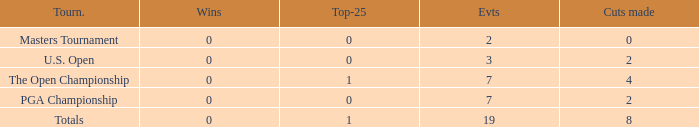What is the Wins of the Top-25 of 1 and 7 Events? 0.0. 